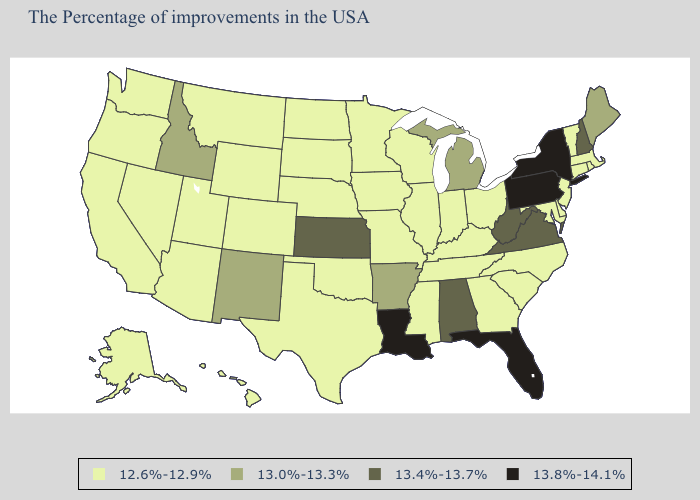Does Maryland have a lower value than South Dakota?
Quick response, please. No. Does California have the highest value in the USA?
Quick response, please. No. What is the highest value in the USA?
Quick response, please. 13.8%-14.1%. Name the states that have a value in the range 13.8%-14.1%?
Give a very brief answer. New York, Pennsylvania, Florida, Louisiana. What is the highest value in the South ?
Write a very short answer. 13.8%-14.1%. What is the lowest value in states that border Wisconsin?
Short answer required. 12.6%-12.9%. Does Oklahoma have the highest value in the USA?
Write a very short answer. No. What is the value of Kansas?
Concise answer only. 13.4%-13.7%. Name the states that have a value in the range 13.8%-14.1%?
Give a very brief answer. New York, Pennsylvania, Florida, Louisiana. How many symbols are there in the legend?
Keep it brief. 4. Name the states that have a value in the range 12.6%-12.9%?
Give a very brief answer. Massachusetts, Rhode Island, Vermont, Connecticut, New Jersey, Delaware, Maryland, North Carolina, South Carolina, Ohio, Georgia, Kentucky, Indiana, Tennessee, Wisconsin, Illinois, Mississippi, Missouri, Minnesota, Iowa, Nebraska, Oklahoma, Texas, South Dakota, North Dakota, Wyoming, Colorado, Utah, Montana, Arizona, Nevada, California, Washington, Oregon, Alaska, Hawaii. Name the states that have a value in the range 13.8%-14.1%?
Short answer required. New York, Pennsylvania, Florida, Louisiana. How many symbols are there in the legend?
Short answer required. 4. Which states have the lowest value in the USA?
Answer briefly. Massachusetts, Rhode Island, Vermont, Connecticut, New Jersey, Delaware, Maryland, North Carolina, South Carolina, Ohio, Georgia, Kentucky, Indiana, Tennessee, Wisconsin, Illinois, Mississippi, Missouri, Minnesota, Iowa, Nebraska, Oklahoma, Texas, South Dakota, North Dakota, Wyoming, Colorado, Utah, Montana, Arizona, Nevada, California, Washington, Oregon, Alaska, Hawaii. What is the value of Tennessee?
Concise answer only. 12.6%-12.9%. 